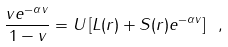Convert formula to latex. <formula><loc_0><loc_0><loc_500><loc_500>\frac { v e ^ { - \alpha v } } { 1 - v } = U \left [ L ( r ) + S ( r ) e ^ { - \alpha v } \right ] \ ,</formula> 